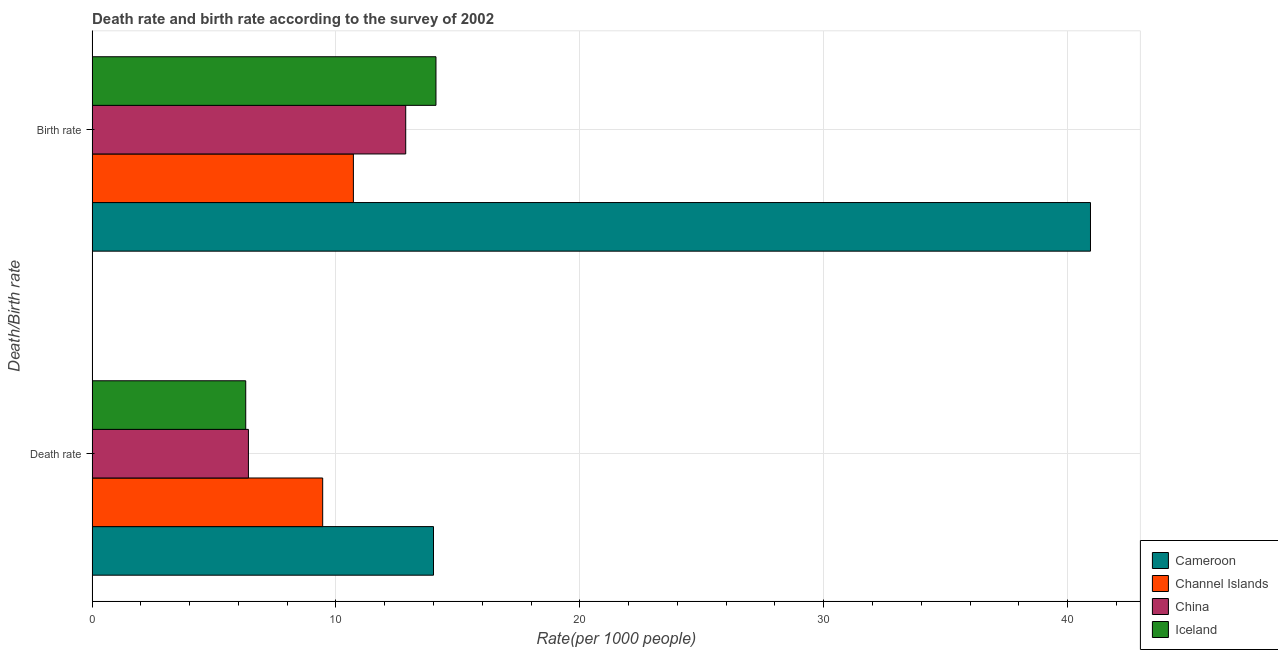How many groups of bars are there?
Give a very brief answer. 2. How many bars are there on the 1st tick from the top?
Make the answer very short. 4. How many bars are there on the 1st tick from the bottom?
Provide a succinct answer. 4. What is the label of the 1st group of bars from the top?
Keep it short and to the point. Birth rate. What is the birth rate in Channel Islands?
Offer a terse response. 10.71. Across all countries, what is the maximum death rate?
Make the answer very short. 14. In which country was the birth rate maximum?
Offer a very short reply. Cameroon. In which country was the death rate minimum?
Ensure brevity in your answer.  Iceland. What is the total birth rate in the graph?
Your answer should be very brief. 78.61. What is the difference between the death rate in Iceland and that in China?
Provide a short and direct response. -0.11. What is the difference between the death rate in Channel Islands and the birth rate in Iceland?
Give a very brief answer. -4.64. What is the average death rate per country?
Make the answer very short. 9.04. What is the difference between the death rate and birth rate in Channel Islands?
Offer a very short reply. -1.26. What is the ratio of the death rate in Cameroon to that in Iceland?
Provide a succinct answer. 2.22. What does the 2nd bar from the top in Birth rate represents?
Provide a succinct answer. China. What does the 3rd bar from the bottom in Birth rate represents?
Provide a succinct answer. China. How many bars are there?
Make the answer very short. 8. Are all the bars in the graph horizontal?
Your answer should be compact. Yes. What is the difference between two consecutive major ticks on the X-axis?
Offer a very short reply. 10. Does the graph contain grids?
Provide a succinct answer. Yes. How many legend labels are there?
Make the answer very short. 4. What is the title of the graph?
Make the answer very short. Death rate and birth rate according to the survey of 2002. Does "Benin" appear as one of the legend labels in the graph?
Give a very brief answer. No. What is the label or title of the X-axis?
Give a very brief answer. Rate(per 1000 people). What is the label or title of the Y-axis?
Your answer should be very brief. Death/Birth rate. What is the Rate(per 1000 people) of Cameroon in Death rate?
Provide a short and direct response. 14. What is the Rate(per 1000 people) of Channel Islands in Death rate?
Offer a very short reply. 9.46. What is the Rate(per 1000 people) of China in Death rate?
Your answer should be very brief. 6.41. What is the Rate(per 1000 people) of Iceland in Death rate?
Make the answer very short. 6.3. What is the Rate(per 1000 people) in Cameroon in Birth rate?
Ensure brevity in your answer.  40.94. What is the Rate(per 1000 people) in Channel Islands in Birth rate?
Give a very brief answer. 10.71. What is the Rate(per 1000 people) of China in Birth rate?
Offer a terse response. 12.86. Across all Death/Birth rate, what is the maximum Rate(per 1000 people) of Cameroon?
Ensure brevity in your answer.  40.94. Across all Death/Birth rate, what is the maximum Rate(per 1000 people) of Channel Islands?
Your answer should be compact. 10.71. Across all Death/Birth rate, what is the maximum Rate(per 1000 people) of China?
Offer a very short reply. 12.86. Across all Death/Birth rate, what is the minimum Rate(per 1000 people) of Cameroon?
Offer a very short reply. 14. Across all Death/Birth rate, what is the minimum Rate(per 1000 people) in Channel Islands?
Give a very brief answer. 9.46. Across all Death/Birth rate, what is the minimum Rate(per 1000 people) in China?
Your answer should be very brief. 6.41. What is the total Rate(per 1000 people) in Cameroon in the graph?
Your answer should be very brief. 54.94. What is the total Rate(per 1000 people) of Channel Islands in the graph?
Provide a succinct answer. 20.17. What is the total Rate(per 1000 people) in China in the graph?
Make the answer very short. 19.27. What is the total Rate(per 1000 people) in Iceland in the graph?
Offer a very short reply. 20.4. What is the difference between the Rate(per 1000 people) in Cameroon in Death rate and that in Birth rate?
Your answer should be compact. -26.94. What is the difference between the Rate(per 1000 people) in Channel Islands in Death rate and that in Birth rate?
Make the answer very short. -1.26. What is the difference between the Rate(per 1000 people) of China in Death rate and that in Birth rate?
Your response must be concise. -6.45. What is the difference between the Rate(per 1000 people) of Iceland in Death rate and that in Birth rate?
Give a very brief answer. -7.8. What is the difference between the Rate(per 1000 people) in Cameroon in Death rate and the Rate(per 1000 people) in Channel Islands in Birth rate?
Provide a short and direct response. 3.29. What is the difference between the Rate(per 1000 people) in Cameroon in Death rate and the Rate(per 1000 people) in China in Birth rate?
Ensure brevity in your answer.  1.14. What is the difference between the Rate(per 1000 people) in Cameroon in Death rate and the Rate(per 1000 people) in Iceland in Birth rate?
Give a very brief answer. -0.1. What is the difference between the Rate(per 1000 people) of Channel Islands in Death rate and the Rate(per 1000 people) of China in Birth rate?
Your answer should be compact. -3.4. What is the difference between the Rate(per 1000 people) of Channel Islands in Death rate and the Rate(per 1000 people) of Iceland in Birth rate?
Provide a succinct answer. -4.64. What is the difference between the Rate(per 1000 people) in China in Death rate and the Rate(per 1000 people) in Iceland in Birth rate?
Provide a succinct answer. -7.69. What is the average Rate(per 1000 people) in Cameroon per Death/Birth rate?
Ensure brevity in your answer.  27.47. What is the average Rate(per 1000 people) of Channel Islands per Death/Birth rate?
Make the answer very short. 10.08. What is the average Rate(per 1000 people) in China per Death/Birth rate?
Your answer should be compact. 9.63. What is the difference between the Rate(per 1000 people) of Cameroon and Rate(per 1000 people) of Channel Islands in Death rate?
Offer a very short reply. 4.54. What is the difference between the Rate(per 1000 people) in Cameroon and Rate(per 1000 people) in China in Death rate?
Keep it short and to the point. 7.59. What is the difference between the Rate(per 1000 people) of Cameroon and Rate(per 1000 people) of Iceland in Death rate?
Offer a terse response. 7.7. What is the difference between the Rate(per 1000 people) of Channel Islands and Rate(per 1000 people) of China in Death rate?
Your response must be concise. 3.04. What is the difference between the Rate(per 1000 people) in Channel Islands and Rate(per 1000 people) in Iceland in Death rate?
Provide a short and direct response. 3.15. What is the difference between the Rate(per 1000 people) of China and Rate(per 1000 people) of Iceland in Death rate?
Provide a short and direct response. 0.11. What is the difference between the Rate(per 1000 people) of Cameroon and Rate(per 1000 people) of Channel Islands in Birth rate?
Make the answer very short. 30.22. What is the difference between the Rate(per 1000 people) in Cameroon and Rate(per 1000 people) in China in Birth rate?
Your response must be concise. 28.08. What is the difference between the Rate(per 1000 people) of Cameroon and Rate(per 1000 people) of Iceland in Birth rate?
Offer a very short reply. 26.84. What is the difference between the Rate(per 1000 people) of Channel Islands and Rate(per 1000 people) of China in Birth rate?
Your answer should be very brief. -2.15. What is the difference between the Rate(per 1000 people) of Channel Islands and Rate(per 1000 people) of Iceland in Birth rate?
Give a very brief answer. -3.39. What is the difference between the Rate(per 1000 people) in China and Rate(per 1000 people) in Iceland in Birth rate?
Your response must be concise. -1.24. What is the ratio of the Rate(per 1000 people) of Cameroon in Death rate to that in Birth rate?
Your answer should be very brief. 0.34. What is the ratio of the Rate(per 1000 people) in Channel Islands in Death rate to that in Birth rate?
Offer a very short reply. 0.88. What is the ratio of the Rate(per 1000 people) in China in Death rate to that in Birth rate?
Your answer should be compact. 0.5. What is the ratio of the Rate(per 1000 people) in Iceland in Death rate to that in Birth rate?
Offer a very short reply. 0.45. What is the difference between the highest and the second highest Rate(per 1000 people) of Cameroon?
Provide a succinct answer. 26.94. What is the difference between the highest and the second highest Rate(per 1000 people) in Channel Islands?
Make the answer very short. 1.26. What is the difference between the highest and the second highest Rate(per 1000 people) of China?
Your answer should be compact. 6.45. What is the difference between the highest and the second highest Rate(per 1000 people) of Iceland?
Make the answer very short. 7.8. What is the difference between the highest and the lowest Rate(per 1000 people) of Cameroon?
Your answer should be very brief. 26.94. What is the difference between the highest and the lowest Rate(per 1000 people) of Channel Islands?
Offer a very short reply. 1.26. What is the difference between the highest and the lowest Rate(per 1000 people) in China?
Offer a very short reply. 6.45. What is the difference between the highest and the lowest Rate(per 1000 people) of Iceland?
Ensure brevity in your answer.  7.8. 